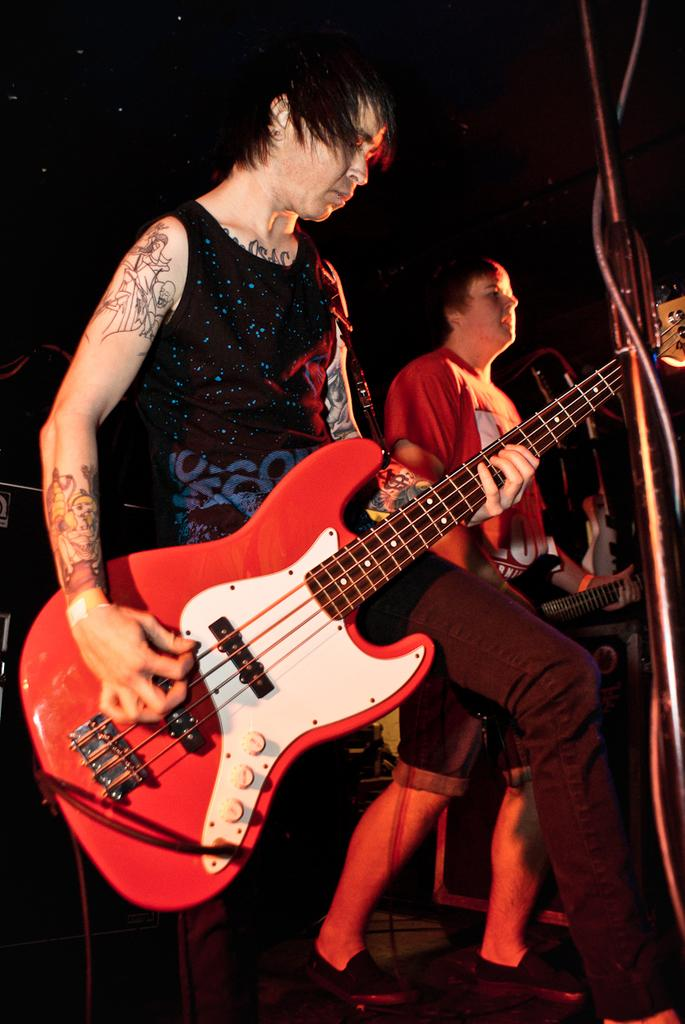What is the man on the left side of the image doing? The man on the left is playing a guitar. What is the man in the middle of the image wearing? The man in the middle is wearing a red t-shirt and trousers. What is the man in the middle of the image doing? The man in the middle is playing a guitar and singing. What grade did the man in the middle receive for his lace-making skills in the image? There is no mention of lace or grades in the image, as it features two men playing guitars and singing. 